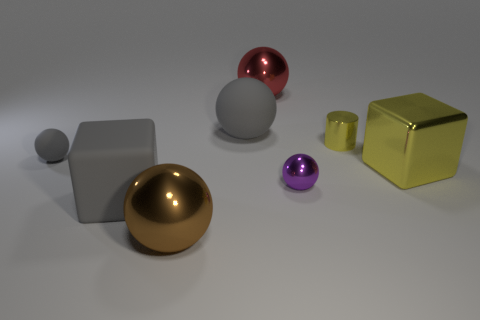Subtract all purple balls. How many balls are left? 4 Subtract all blue balls. Subtract all gray cubes. How many balls are left? 5 Add 1 big cyan rubber things. How many objects exist? 9 Subtract all blocks. How many objects are left? 6 Add 5 yellow metal blocks. How many yellow metal blocks are left? 6 Add 1 big gray objects. How many big gray objects exist? 3 Subtract 0 cyan cylinders. How many objects are left? 8 Subtract all gray objects. Subtract all yellow matte balls. How many objects are left? 5 